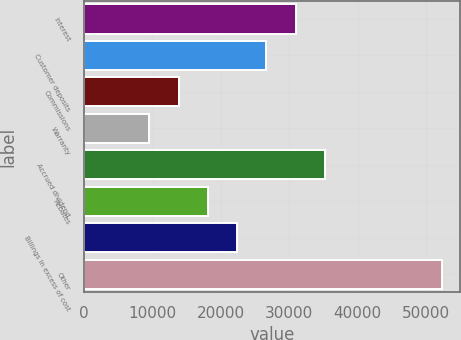<chart> <loc_0><loc_0><loc_500><loc_500><bar_chart><fcel>Interest<fcel>Customer deposits<fcel>Commissions<fcel>Warranty<fcel>Accrued dividend<fcel>Rebates<fcel>Billings in excess of cost<fcel>Other<nl><fcel>30955.5<fcel>26671.8<fcel>13820.7<fcel>9537<fcel>35239.2<fcel>18104.4<fcel>22388.1<fcel>52374<nl></chart> 